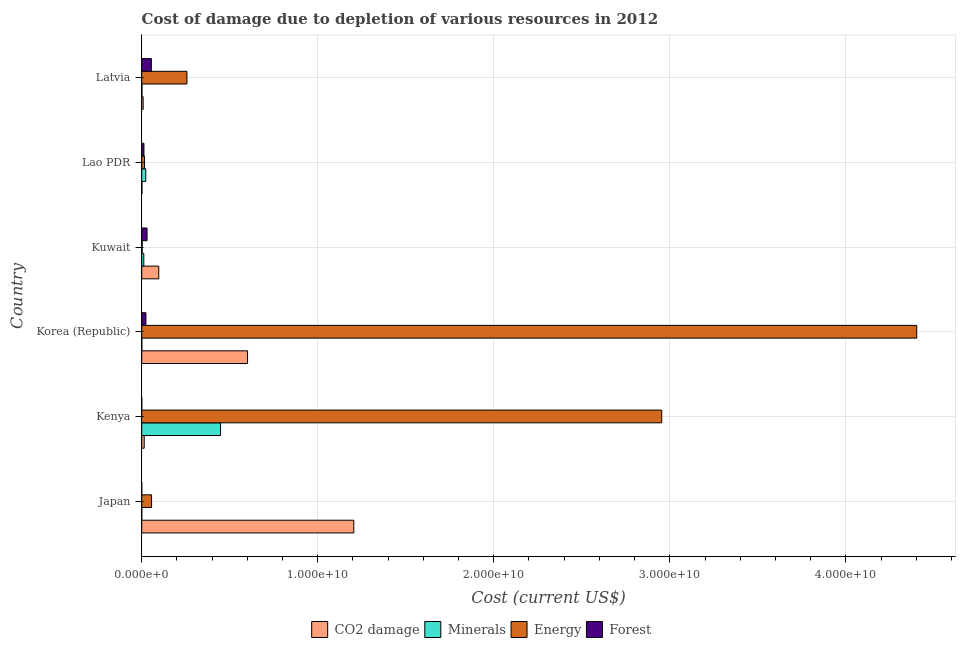How many different coloured bars are there?
Offer a terse response. 4. Are the number of bars per tick equal to the number of legend labels?
Your answer should be very brief. Yes. How many bars are there on the 2nd tick from the top?
Provide a succinct answer. 4. What is the label of the 5th group of bars from the top?
Your answer should be very brief. Kenya. In how many cases, is the number of bars for a given country not equal to the number of legend labels?
Give a very brief answer. 0. What is the cost of damage due to depletion of forests in Latvia?
Give a very brief answer. 5.47e+08. Across all countries, what is the maximum cost of damage due to depletion of coal?
Provide a short and direct response. 1.20e+1. Across all countries, what is the minimum cost of damage due to depletion of coal?
Keep it short and to the point. 1.30e+07. In which country was the cost of damage due to depletion of forests maximum?
Provide a succinct answer. Latvia. In which country was the cost of damage due to depletion of energy minimum?
Provide a short and direct response. Kuwait. What is the total cost of damage due to depletion of energy in the graph?
Offer a terse response. 7.69e+1. What is the difference between the cost of damage due to depletion of minerals in Japan and that in Latvia?
Make the answer very short. -1.47e+07. What is the difference between the cost of damage due to depletion of forests in Korea (Republic) and the cost of damage due to depletion of energy in Lao PDR?
Your response must be concise. 7.86e+07. What is the average cost of damage due to depletion of energy per country?
Give a very brief answer. 1.28e+1. What is the difference between the cost of damage due to depletion of minerals and cost of damage due to depletion of energy in Latvia?
Offer a very short reply. -2.55e+09. What is the ratio of the cost of damage due to depletion of coal in Kenya to that in Latvia?
Your answer should be compact. 1.74. Is the cost of damage due to depletion of forests in Lao PDR less than that in Latvia?
Keep it short and to the point. Yes. Is the difference between the cost of damage due to depletion of coal in Japan and Korea (Republic) greater than the difference between the cost of damage due to depletion of energy in Japan and Korea (Republic)?
Make the answer very short. Yes. What is the difference between the highest and the second highest cost of damage due to depletion of energy?
Give a very brief answer. 1.45e+1. What is the difference between the highest and the lowest cost of damage due to depletion of energy?
Your answer should be very brief. 4.40e+1. Is it the case that in every country, the sum of the cost of damage due to depletion of minerals and cost of damage due to depletion of coal is greater than the sum of cost of damage due to depletion of energy and cost of damage due to depletion of forests?
Your answer should be compact. No. What does the 1st bar from the top in Kuwait represents?
Ensure brevity in your answer.  Forest. What does the 3rd bar from the bottom in Korea (Republic) represents?
Make the answer very short. Energy. Is it the case that in every country, the sum of the cost of damage due to depletion of coal and cost of damage due to depletion of minerals is greater than the cost of damage due to depletion of energy?
Keep it short and to the point. No. Are all the bars in the graph horizontal?
Provide a succinct answer. Yes. How many countries are there in the graph?
Offer a very short reply. 6. What is the difference between two consecutive major ticks on the X-axis?
Provide a short and direct response. 1.00e+1. Does the graph contain grids?
Your answer should be compact. Yes. How many legend labels are there?
Your answer should be very brief. 4. What is the title of the graph?
Offer a terse response. Cost of damage due to depletion of various resources in 2012 . Does "Source data assessment" appear as one of the legend labels in the graph?
Offer a very short reply. No. What is the label or title of the X-axis?
Keep it short and to the point. Cost (current US$). What is the Cost (current US$) in CO2 damage in Japan?
Offer a terse response. 1.20e+1. What is the Cost (current US$) in Minerals in Japan?
Keep it short and to the point. 3.50e+05. What is the Cost (current US$) of Energy in Japan?
Provide a short and direct response. 5.60e+08. What is the Cost (current US$) in Forest in Japan?
Offer a terse response. 2.02e+05. What is the Cost (current US$) in CO2 damage in Kenya?
Your response must be concise. 1.41e+08. What is the Cost (current US$) of Minerals in Kenya?
Ensure brevity in your answer.  4.48e+09. What is the Cost (current US$) of Energy in Kenya?
Keep it short and to the point. 2.95e+1. What is the Cost (current US$) in Forest in Kenya?
Your answer should be very brief. 1.33e+06. What is the Cost (current US$) in CO2 damage in Korea (Republic)?
Make the answer very short. 6.01e+09. What is the Cost (current US$) of Minerals in Korea (Republic)?
Make the answer very short. 8.17e+06. What is the Cost (current US$) in Energy in Korea (Republic)?
Your answer should be compact. 4.40e+1. What is the Cost (current US$) of Forest in Korea (Republic)?
Your answer should be compact. 2.37e+08. What is the Cost (current US$) in CO2 damage in Kuwait?
Keep it short and to the point. 9.68e+08. What is the Cost (current US$) of Minerals in Kuwait?
Give a very brief answer. 1.19e+08. What is the Cost (current US$) in Energy in Kuwait?
Ensure brevity in your answer.  2.46e+07. What is the Cost (current US$) of Forest in Kuwait?
Ensure brevity in your answer.  3.02e+08. What is the Cost (current US$) of CO2 damage in Lao PDR?
Your response must be concise. 1.30e+07. What is the Cost (current US$) in Minerals in Lao PDR?
Your answer should be very brief. 2.30e+08. What is the Cost (current US$) in Energy in Lao PDR?
Your answer should be very brief. 1.59e+08. What is the Cost (current US$) of Forest in Lao PDR?
Offer a very short reply. 1.27e+08. What is the Cost (current US$) in CO2 damage in Latvia?
Ensure brevity in your answer.  8.15e+07. What is the Cost (current US$) of Minerals in Latvia?
Your response must be concise. 1.51e+07. What is the Cost (current US$) of Energy in Latvia?
Ensure brevity in your answer.  2.57e+09. What is the Cost (current US$) in Forest in Latvia?
Offer a very short reply. 5.47e+08. Across all countries, what is the maximum Cost (current US$) of CO2 damage?
Keep it short and to the point. 1.20e+1. Across all countries, what is the maximum Cost (current US$) of Minerals?
Keep it short and to the point. 4.48e+09. Across all countries, what is the maximum Cost (current US$) in Energy?
Offer a very short reply. 4.40e+1. Across all countries, what is the maximum Cost (current US$) in Forest?
Your answer should be compact. 5.47e+08. Across all countries, what is the minimum Cost (current US$) in CO2 damage?
Your response must be concise. 1.30e+07. Across all countries, what is the minimum Cost (current US$) in Minerals?
Make the answer very short. 3.50e+05. Across all countries, what is the minimum Cost (current US$) of Energy?
Make the answer very short. 2.46e+07. Across all countries, what is the minimum Cost (current US$) of Forest?
Offer a terse response. 2.02e+05. What is the total Cost (current US$) of CO2 damage in the graph?
Provide a succinct answer. 1.93e+1. What is the total Cost (current US$) of Minerals in the graph?
Your answer should be compact. 4.85e+09. What is the total Cost (current US$) in Energy in the graph?
Make the answer very short. 7.69e+1. What is the total Cost (current US$) of Forest in the graph?
Your response must be concise. 1.22e+09. What is the difference between the Cost (current US$) in CO2 damage in Japan and that in Kenya?
Offer a very short reply. 1.19e+1. What is the difference between the Cost (current US$) in Minerals in Japan and that in Kenya?
Give a very brief answer. -4.48e+09. What is the difference between the Cost (current US$) of Energy in Japan and that in Kenya?
Offer a terse response. -2.90e+1. What is the difference between the Cost (current US$) in Forest in Japan and that in Kenya?
Ensure brevity in your answer.  -1.12e+06. What is the difference between the Cost (current US$) of CO2 damage in Japan and that in Korea (Republic)?
Provide a short and direct response. 6.04e+09. What is the difference between the Cost (current US$) of Minerals in Japan and that in Korea (Republic)?
Provide a succinct answer. -7.82e+06. What is the difference between the Cost (current US$) of Energy in Japan and that in Korea (Republic)?
Offer a very short reply. -4.35e+1. What is the difference between the Cost (current US$) in Forest in Japan and that in Korea (Republic)?
Offer a very short reply. -2.37e+08. What is the difference between the Cost (current US$) in CO2 damage in Japan and that in Kuwait?
Your response must be concise. 1.11e+1. What is the difference between the Cost (current US$) in Minerals in Japan and that in Kuwait?
Make the answer very short. -1.19e+08. What is the difference between the Cost (current US$) in Energy in Japan and that in Kuwait?
Provide a succinct answer. 5.35e+08. What is the difference between the Cost (current US$) of Forest in Japan and that in Kuwait?
Offer a terse response. -3.02e+08. What is the difference between the Cost (current US$) in CO2 damage in Japan and that in Lao PDR?
Give a very brief answer. 1.20e+1. What is the difference between the Cost (current US$) of Minerals in Japan and that in Lao PDR?
Keep it short and to the point. -2.30e+08. What is the difference between the Cost (current US$) of Energy in Japan and that in Lao PDR?
Your answer should be compact. 4.01e+08. What is the difference between the Cost (current US$) of Forest in Japan and that in Lao PDR?
Offer a terse response. -1.27e+08. What is the difference between the Cost (current US$) of CO2 damage in Japan and that in Latvia?
Give a very brief answer. 1.20e+1. What is the difference between the Cost (current US$) of Minerals in Japan and that in Latvia?
Your answer should be very brief. -1.47e+07. What is the difference between the Cost (current US$) of Energy in Japan and that in Latvia?
Your answer should be compact. -2.01e+09. What is the difference between the Cost (current US$) of Forest in Japan and that in Latvia?
Offer a terse response. -5.47e+08. What is the difference between the Cost (current US$) in CO2 damage in Kenya and that in Korea (Republic)?
Your answer should be compact. -5.87e+09. What is the difference between the Cost (current US$) in Minerals in Kenya and that in Korea (Republic)?
Provide a succinct answer. 4.47e+09. What is the difference between the Cost (current US$) in Energy in Kenya and that in Korea (Republic)?
Provide a short and direct response. -1.45e+1. What is the difference between the Cost (current US$) in Forest in Kenya and that in Korea (Republic)?
Offer a terse response. -2.36e+08. What is the difference between the Cost (current US$) in CO2 damage in Kenya and that in Kuwait?
Give a very brief answer. -8.26e+08. What is the difference between the Cost (current US$) in Minerals in Kenya and that in Kuwait?
Offer a very short reply. 4.36e+09. What is the difference between the Cost (current US$) in Energy in Kenya and that in Kuwait?
Provide a short and direct response. 2.95e+1. What is the difference between the Cost (current US$) of Forest in Kenya and that in Kuwait?
Provide a succinct answer. -3.01e+08. What is the difference between the Cost (current US$) of CO2 damage in Kenya and that in Lao PDR?
Offer a very short reply. 1.28e+08. What is the difference between the Cost (current US$) in Minerals in Kenya and that in Lao PDR?
Make the answer very short. 4.25e+09. What is the difference between the Cost (current US$) in Energy in Kenya and that in Lao PDR?
Give a very brief answer. 2.94e+1. What is the difference between the Cost (current US$) in Forest in Kenya and that in Lao PDR?
Provide a short and direct response. -1.26e+08. What is the difference between the Cost (current US$) in CO2 damage in Kenya and that in Latvia?
Ensure brevity in your answer.  5.99e+07. What is the difference between the Cost (current US$) in Minerals in Kenya and that in Latvia?
Provide a succinct answer. 4.46e+09. What is the difference between the Cost (current US$) in Energy in Kenya and that in Latvia?
Give a very brief answer. 2.70e+1. What is the difference between the Cost (current US$) of Forest in Kenya and that in Latvia?
Make the answer very short. -5.46e+08. What is the difference between the Cost (current US$) of CO2 damage in Korea (Republic) and that in Kuwait?
Ensure brevity in your answer.  5.04e+09. What is the difference between the Cost (current US$) of Minerals in Korea (Republic) and that in Kuwait?
Ensure brevity in your answer.  -1.11e+08. What is the difference between the Cost (current US$) in Energy in Korea (Republic) and that in Kuwait?
Offer a very short reply. 4.40e+1. What is the difference between the Cost (current US$) in Forest in Korea (Republic) and that in Kuwait?
Ensure brevity in your answer.  -6.49e+07. What is the difference between the Cost (current US$) of CO2 damage in Korea (Republic) and that in Lao PDR?
Your response must be concise. 6.00e+09. What is the difference between the Cost (current US$) of Minerals in Korea (Republic) and that in Lao PDR?
Make the answer very short. -2.22e+08. What is the difference between the Cost (current US$) in Energy in Korea (Republic) and that in Lao PDR?
Your answer should be compact. 4.39e+1. What is the difference between the Cost (current US$) of Forest in Korea (Republic) and that in Lao PDR?
Provide a short and direct response. 1.11e+08. What is the difference between the Cost (current US$) of CO2 damage in Korea (Republic) and that in Latvia?
Ensure brevity in your answer.  5.93e+09. What is the difference between the Cost (current US$) in Minerals in Korea (Republic) and that in Latvia?
Offer a very short reply. -6.92e+06. What is the difference between the Cost (current US$) in Energy in Korea (Republic) and that in Latvia?
Your response must be concise. 4.15e+1. What is the difference between the Cost (current US$) in Forest in Korea (Republic) and that in Latvia?
Ensure brevity in your answer.  -3.10e+08. What is the difference between the Cost (current US$) in CO2 damage in Kuwait and that in Lao PDR?
Your answer should be very brief. 9.55e+08. What is the difference between the Cost (current US$) of Minerals in Kuwait and that in Lao PDR?
Keep it short and to the point. -1.12e+08. What is the difference between the Cost (current US$) of Energy in Kuwait and that in Lao PDR?
Your answer should be compact. -1.34e+08. What is the difference between the Cost (current US$) in Forest in Kuwait and that in Lao PDR?
Ensure brevity in your answer.  1.75e+08. What is the difference between the Cost (current US$) in CO2 damage in Kuwait and that in Latvia?
Keep it short and to the point. 8.86e+08. What is the difference between the Cost (current US$) of Minerals in Kuwait and that in Latvia?
Make the answer very short. 1.04e+08. What is the difference between the Cost (current US$) of Energy in Kuwait and that in Latvia?
Offer a very short reply. -2.54e+09. What is the difference between the Cost (current US$) of Forest in Kuwait and that in Latvia?
Ensure brevity in your answer.  -2.45e+08. What is the difference between the Cost (current US$) of CO2 damage in Lao PDR and that in Latvia?
Provide a short and direct response. -6.86e+07. What is the difference between the Cost (current US$) in Minerals in Lao PDR and that in Latvia?
Offer a very short reply. 2.15e+08. What is the difference between the Cost (current US$) in Energy in Lao PDR and that in Latvia?
Keep it short and to the point. -2.41e+09. What is the difference between the Cost (current US$) of Forest in Lao PDR and that in Latvia?
Keep it short and to the point. -4.20e+08. What is the difference between the Cost (current US$) in CO2 damage in Japan and the Cost (current US$) in Minerals in Kenya?
Ensure brevity in your answer.  7.57e+09. What is the difference between the Cost (current US$) in CO2 damage in Japan and the Cost (current US$) in Energy in Kenya?
Make the answer very short. -1.75e+1. What is the difference between the Cost (current US$) of CO2 damage in Japan and the Cost (current US$) of Forest in Kenya?
Keep it short and to the point. 1.20e+1. What is the difference between the Cost (current US$) in Minerals in Japan and the Cost (current US$) in Energy in Kenya?
Your response must be concise. -2.95e+1. What is the difference between the Cost (current US$) in Minerals in Japan and the Cost (current US$) in Forest in Kenya?
Your answer should be compact. -9.76e+05. What is the difference between the Cost (current US$) of Energy in Japan and the Cost (current US$) of Forest in Kenya?
Give a very brief answer. 5.58e+08. What is the difference between the Cost (current US$) of CO2 damage in Japan and the Cost (current US$) of Minerals in Korea (Republic)?
Offer a terse response. 1.20e+1. What is the difference between the Cost (current US$) in CO2 damage in Japan and the Cost (current US$) in Energy in Korea (Republic)?
Ensure brevity in your answer.  -3.20e+1. What is the difference between the Cost (current US$) in CO2 damage in Japan and the Cost (current US$) in Forest in Korea (Republic)?
Give a very brief answer. 1.18e+1. What is the difference between the Cost (current US$) in Minerals in Japan and the Cost (current US$) in Energy in Korea (Republic)?
Offer a very short reply. -4.40e+1. What is the difference between the Cost (current US$) of Minerals in Japan and the Cost (current US$) of Forest in Korea (Republic)?
Give a very brief answer. -2.37e+08. What is the difference between the Cost (current US$) in Energy in Japan and the Cost (current US$) in Forest in Korea (Republic)?
Make the answer very short. 3.22e+08. What is the difference between the Cost (current US$) of CO2 damage in Japan and the Cost (current US$) of Minerals in Kuwait?
Your answer should be compact. 1.19e+1. What is the difference between the Cost (current US$) of CO2 damage in Japan and the Cost (current US$) of Energy in Kuwait?
Offer a terse response. 1.20e+1. What is the difference between the Cost (current US$) in CO2 damage in Japan and the Cost (current US$) in Forest in Kuwait?
Keep it short and to the point. 1.17e+1. What is the difference between the Cost (current US$) of Minerals in Japan and the Cost (current US$) of Energy in Kuwait?
Your response must be concise. -2.43e+07. What is the difference between the Cost (current US$) of Minerals in Japan and the Cost (current US$) of Forest in Kuwait?
Ensure brevity in your answer.  -3.02e+08. What is the difference between the Cost (current US$) in Energy in Japan and the Cost (current US$) in Forest in Kuwait?
Give a very brief answer. 2.57e+08. What is the difference between the Cost (current US$) of CO2 damage in Japan and the Cost (current US$) of Minerals in Lao PDR?
Provide a succinct answer. 1.18e+1. What is the difference between the Cost (current US$) in CO2 damage in Japan and the Cost (current US$) in Energy in Lao PDR?
Give a very brief answer. 1.19e+1. What is the difference between the Cost (current US$) in CO2 damage in Japan and the Cost (current US$) in Forest in Lao PDR?
Provide a succinct answer. 1.19e+1. What is the difference between the Cost (current US$) in Minerals in Japan and the Cost (current US$) in Energy in Lao PDR?
Offer a terse response. -1.59e+08. What is the difference between the Cost (current US$) of Minerals in Japan and the Cost (current US$) of Forest in Lao PDR?
Ensure brevity in your answer.  -1.27e+08. What is the difference between the Cost (current US$) in Energy in Japan and the Cost (current US$) in Forest in Lao PDR?
Offer a very short reply. 4.33e+08. What is the difference between the Cost (current US$) in CO2 damage in Japan and the Cost (current US$) in Minerals in Latvia?
Offer a terse response. 1.20e+1. What is the difference between the Cost (current US$) in CO2 damage in Japan and the Cost (current US$) in Energy in Latvia?
Give a very brief answer. 9.48e+09. What is the difference between the Cost (current US$) in CO2 damage in Japan and the Cost (current US$) in Forest in Latvia?
Offer a very short reply. 1.15e+1. What is the difference between the Cost (current US$) of Minerals in Japan and the Cost (current US$) of Energy in Latvia?
Offer a terse response. -2.57e+09. What is the difference between the Cost (current US$) in Minerals in Japan and the Cost (current US$) in Forest in Latvia?
Your answer should be compact. -5.47e+08. What is the difference between the Cost (current US$) of Energy in Japan and the Cost (current US$) of Forest in Latvia?
Your answer should be very brief. 1.25e+07. What is the difference between the Cost (current US$) of CO2 damage in Kenya and the Cost (current US$) of Minerals in Korea (Republic)?
Your answer should be compact. 1.33e+08. What is the difference between the Cost (current US$) in CO2 damage in Kenya and the Cost (current US$) in Energy in Korea (Republic)?
Ensure brevity in your answer.  -4.39e+1. What is the difference between the Cost (current US$) of CO2 damage in Kenya and the Cost (current US$) of Forest in Korea (Republic)?
Your answer should be very brief. -9.61e+07. What is the difference between the Cost (current US$) in Minerals in Kenya and the Cost (current US$) in Energy in Korea (Republic)?
Your response must be concise. -3.96e+1. What is the difference between the Cost (current US$) in Minerals in Kenya and the Cost (current US$) in Forest in Korea (Republic)?
Keep it short and to the point. 4.24e+09. What is the difference between the Cost (current US$) in Energy in Kenya and the Cost (current US$) in Forest in Korea (Republic)?
Provide a short and direct response. 2.93e+1. What is the difference between the Cost (current US$) in CO2 damage in Kenya and the Cost (current US$) in Minerals in Kuwait?
Offer a very short reply. 2.25e+07. What is the difference between the Cost (current US$) in CO2 damage in Kenya and the Cost (current US$) in Energy in Kuwait?
Your answer should be compact. 1.17e+08. What is the difference between the Cost (current US$) of CO2 damage in Kenya and the Cost (current US$) of Forest in Kuwait?
Give a very brief answer. -1.61e+08. What is the difference between the Cost (current US$) of Minerals in Kenya and the Cost (current US$) of Energy in Kuwait?
Your answer should be very brief. 4.45e+09. What is the difference between the Cost (current US$) in Minerals in Kenya and the Cost (current US$) in Forest in Kuwait?
Offer a very short reply. 4.18e+09. What is the difference between the Cost (current US$) in Energy in Kenya and the Cost (current US$) in Forest in Kuwait?
Your response must be concise. 2.92e+1. What is the difference between the Cost (current US$) of CO2 damage in Kenya and the Cost (current US$) of Minerals in Lao PDR?
Offer a terse response. -8.90e+07. What is the difference between the Cost (current US$) of CO2 damage in Kenya and the Cost (current US$) of Energy in Lao PDR?
Give a very brief answer. -1.75e+07. What is the difference between the Cost (current US$) in CO2 damage in Kenya and the Cost (current US$) in Forest in Lao PDR?
Your answer should be very brief. 1.45e+07. What is the difference between the Cost (current US$) of Minerals in Kenya and the Cost (current US$) of Energy in Lao PDR?
Keep it short and to the point. 4.32e+09. What is the difference between the Cost (current US$) in Minerals in Kenya and the Cost (current US$) in Forest in Lao PDR?
Give a very brief answer. 4.35e+09. What is the difference between the Cost (current US$) of Energy in Kenya and the Cost (current US$) of Forest in Lao PDR?
Offer a very short reply. 2.94e+1. What is the difference between the Cost (current US$) in CO2 damage in Kenya and the Cost (current US$) in Minerals in Latvia?
Provide a succinct answer. 1.26e+08. What is the difference between the Cost (current US$) of CO2 damage in Kenya and the Cost (current US$) of Energy in Latvia?
Make the answer very short. -2.43e+09. What is the difference between the Cost (current US$) of CO2 damage in Kenya and the Cost (current US$) of Forest in Latvia?
Give a very brief answer. -4.06e+08. What is the difference between the Cost (current US$) of Minerals in Kenya and the Cost (current US$) of Energy in Latvia?
Your answer should be compact. 1.91e+09. What is the difference between the Cost (current US$) of Minerals in Kenya and the Cost (current US$) of Forest in Latvia?
Make the answer very short. 3.93e+09. What is the difference between the Cost (current US$) of Energy in Kenya and the Cost (current US$) of Forest in Latvia?
Your answer should be very brief. 2.90e+1. What is the difference between the Cost (current US$) of CO2 damage in Korea (Republic) and the Cost (current US$) of Minerals in Kuwait?
Your answer should be very brief. 5.89e+09. What is the difference between the Cost (current US$) of CO2 damage in Korea (Republic) and the Cost (current US$) of Energy in Kuwait?
Keep it short and to the point. 5.99e+09. What is the difference between the Cost (current US$) in CO2 damage in Korea (Republic) and the Cost (current US$) in Forest in Kuwait?
Give a very brief answer. 5.71e+09. What is the difference between the Cost (current US$) in Minerals in Korea (Republic) and the Cost (current US$) in Energy in Kuwait?
Your response must be concise. -1.65e+07. What is the difference between the Cost (current US$) in Minerals in Korea (Republic) and the Cost (current US$) in Forest in Kuwait?
Provide a short and direct response. -2.94e+08. What is the difference between the Cost (current US$) of Energy in Korea (Republic) and the Cost (current US$) of Forest in Kuwait?
Make the answer very short. 4.37e+1. What is the difference between the Cost (current US$) of CO2 damage in Korea (Republic) and the Cost (current US$) of Minerals in Lao PDR?
Provide a short and direct response. 5.78e+09. What is the difference between the Cost (current US$) in CO2 damage in Korea (Republic) and the Cost (current US$) in Energy in Lao PDR?
Your answer should be compact. 5.85e+09. What is the difference between the Cost (current US$) in CO2 damage in Korea (Republic) and the Cost (current US$) in Forest in Lao PDR?
Your response must be concise. 5.88e+09. What is the difference between the Cost (current US$) of Minerals in Korea (Republic) and the Cost (current US$) of Energy in Lao PDR?
Provide a succinct answer. -1.51e+08. What is the difference between the Cost (current US$) in Minerals in Korea (Republic) and the Cost (current US$) in Forest in Lao PDR?
Keep it short and to the point. -1.19e+08. What is the difference between the Cost (current US$) in Energy in Korea (Republic) and the Cost (current US$) in Forest in Lao PDR?
Your response must be concise. 4.39e+1. What is the difference between the Cost (current US$) of CO2 damage in Korea (Republic) and the Cost (current US$) of Minerals in Latvia?
Keep it short and to the point. 6.00e+09. What is the difference between the Cost (current US$) of CO2 damage in Korea (Republic) and the Cost (current US$) of Energy in Latvia?
Keep it short and to the point. 3.44e+09. What is the difference between the Cost (current US$) in CO2 damage in Korea (Republic) and the Cost (current US$) in Forest in Latvia?
Offer a terse response. 5.46e+09. What is the difference between the Cost (current US$) of Minerals in Korea (Republic) and the Cost (current US$) of Energy in Latvia?
Provide a succinct answer. -2.56e+09. What is the difference between the Cost (current US$) in Minerals in Korea (Republic) and the Cost (current US$) in Forest in Latvia?
Provide a short and direct response. -5.39e+08. What is the difference between the Cost (current US$) in Energy in Korea (Republic) and the Cost (current US$) in Forest in Latvia?
Give a very brief answer. 4.35e+1. What is the difference between the Cost (current US$) of CO2 damage in Kuwait and the Cost (current US$) of Minerals in Lao PDR?
Ensure brevity in your answer.  7.37e+08. What is the difference between the Cost (current US$) of CO2 damage in Kuwait and the Cost (current US$) of Energy in Lao PDR?
Your answer should be very brief. 8.09e+08. What is the difference between the Cost (current US$) of CO2 damage in Kuwait and the Cost (current US$) of Forest in Lao PDR?
Keep it short and to the point. 8.41e+08. What is the difference between the Cost (current US$) in Minerals in Kuwait and the Cost (current US$) in Energy in Lao PDR?
Give a very brief answer. -4.00e+07. What is the difference between the Cost (current US$) in Minerals in Kuwait and the Cost (current US$) in Forest in Lao PDR?
Provide a short and direct response. -8.04e+06. What is the difference between the Cost (current US$) of Energy in Kuwait and the Cost (current US$) of Forest in Lao PDR?
Provide a succinct answer. -1.02e+08. What is the difference between the Cost (current US$) in CO2 damage in Kuwait and the Cost (current US$) in Minerals in Latvia?
Provide a succinct answer. 9.53e+08. What is the difference between the Cost (current US$) in CO2 damage in Kuwait and the Cost (current US$) in Energy in Latvia?
Ensure brevity in your answer.  -1.60e+09. What is the difference between the Cost (current US$) in CO2 damage in Kuwait and the Cost (current US$) in Forest in Latvia?
Offer a very short reply. 4.21e+08. What is the difference between the Cost (current US$) of Minerals in Kuwait and the Cost (current US$) of Energy in Latvia?
Give a very brief answer. -2.45e+09. What is the difference between the Cost (current US$) of Minerals in Kuwait and the Cost (current US$) of Forest in Latvia?
Ensure brevity in your answer.  -4.28e+08. What is the difference between the Cost (current US$) of Energy in Kuwait and the Cost (current US$) of Forest in Latvia?
Make the answer very short. -5.22e+08. What is the difference between the Cost (current US$) in CO2 damage in Lao PDR and the Cost (current US$) in Minerals in Latvia?
Your answer should be compact. -2.13e+06. What is the difference between the Cost (current US$) of CO2 damage in Lao PDR and the Cost (current US$) of Energy in Latvia?
Ensure brevity in your answer.  -2.56e+09. What is the difference between the Cost (current US$) of CO2 damage in Lao PDR and the Cost (current US$) of Forest in Latvia?
Give a very brief answer. -5.34e+08. What is the difference between the Cost (current US$) in Minerals in Lao PDR and the Cost (current US$) in Energy in Latvia?
Offer a very short reply. -2.34e+09. What is the difference between the Cost (current US$) in Minerals in Lao PDR and the Cost (current US$) in Forest in Latvia?
Offer a terse response. -3.17e+08. What is the difference between the Cost (current US$) in Energy in Lao PDR and the Cost (current US$) in Forest in Latvia?
Offer a very short reply. -3.88e+08. What is the average Cost (current US$) of CO2 damage per country?
Offer a very short reply. 3.21e+09. What is the average Cost (current US$) in Minerals per country?
Provide a short and direct response. 8.08e+08. What is the average Cost (current US$) in Energy per country?
Offer a terse response. 1.28e+1. What is the average Cost (current US$) of Forest per country?
Keep it short and to the point. 2.03e+08. What is the difference between the Cost (current US$) of CO2 damage and Cost (current US$) of Minerals in Japan?
Provide a short and direct response. 1.20e+1. What is the difference between the Cost (current US$) in CO2 damage and Cost (current US$) in Energy in Japan?
Keep it short and to the point. 1.15e+1. What is the difference between the Cost (current US$) of CO2 damage and Cost (current US$) of Forest in Japan?
Your response must be concise. 1.20e+1. What is the difference between the Cost (current US$) in Minerals and Cost (current US$) in Energy in Japan?
Your answer should be very brief. -5.59e+08. What is the difference between the Cost (current US$) in Minerals and Cost (current US$) in Forest in Japan?
Your response must be concise. 1.48e+05. What is the difference between the Cost (current US$) in Energy and Cost (current US$) in Forest in Japan?
Keep it short and to the point. 5.59e+08. What is the difference between the Cost (current US$) in CO2 damage and Cost (current US$) in Minerals in Kenya?
Your answer should be very brief. -4.34e+09. What is the difference between the Cost (current US$) of CO2 damage and Cost (current US$) of Energy in Kenya?
Ensure brevity in your answer.  -2.94e+1. What is the difference between the Cost (current US$) in CO2 damage and Cost (current US$) in Forest in Kenya?
Offer a terse response. 1.40e+08. What is the difference between the Cost (current US$) in Minerals and Cost (current US$) in Energy in Kenya?
Your answer should be compact. -2.51e+1. What is the difference between the Cost (current US$) in Minerals and Cost (current US$) in Forest in Kenya?
Provide a short and direct response. 4.48e+09. What is the difference between the Cost (current US$) in Energy and Cost (current US$) in Forest in Kenya?
Keep it short and to the point. 2.95e+1. What is the difference between the Cost (current US$) in CO2 damage and Cost (current US$) in Minerals in Korea (Republic)?
Ensure brevity in your answer.  6.00e+09. What is the difference between the Cost (current US$) of CO2 damage and Cost (current US$) of Energy in Korea (Republic)?
Ensure brevity in your answer.  -3.80e+1. What is the difference between the Cost (current US$) in CO2 damage and Cost (current US$) in Forest in Korea (Republic)?
Offer a very short reply. 5.77e+09. What is the difference between the Cost (current US$) of Minerals and Cost (current US$) of Energy in Korea (Republic)?
Give a very brief answer. -4.40e+1. What is the difference between the Cost (current US$) of Minerals and Cost (current US$) of Forest in Korea (Republic)?
Your answer should be very brief. -2.29e+08. What is the difference between the Cost (current US$) in Energy and Cost (current US$) in Forest in Korea (Republic)?
Keep it short and to the point. 4.38e+1. What is the difference between the Cost (current US$) in CO2 damage and Cost (current US$) in Minerals in Kuwait?
Ensure brevity in your answer.  8.49e+08. What is the difference between the Cost (current US$) in CO2 damage and Cost (current US$) in Energy in Kuwait?
Give a very brief answer. 9.43e+08. What is the difference between the Cost (current US$) in CO2 damage and Cost (current US$) in Forest in Kuwait?
Your answer should be very brief. 6.65e+08. What is the difference between the Cost (current US$) in Minerals and Cost (current US$) in Energy in Kuwait?
Provide a succinct answer. 9.43e+07. What is the difference between the Cost (current US$) in Minerals and Cost (current US$) in Forest in Kuwait?
Your answer should be very brief. -1.84e+08. What is the difference between the Cost (current US$) of Energy and Cost (current US$) of Forest in Kuwait?
Ensure brevity in your answer.  -2.78e+08. What is the difference between the Cost (current US$) of CO2 damage and Cost (current US$) of Minerals in Lao PDR?
Give a very brief answer. -2.18e+08. What is the difference between the Cost (current US$) in CO2 damage and Cost (current US$) in Energy in Lao PDR?
Give a very brief answer. -1.46e+08. What is the difference between the Cost (current US$) of CO2 damage and Cost (current US$) of Forest in Lao PDR?
Make the answer very short. -1.14e+08. What is the difference between the Cost (current US$) in Minerals and Cost (current US$) in Energy in Lao PDR?
Your answer should be very brief. 7.16e+07. What is the difference between the Cost (current US$) in Minerals and Cost (current US$) in Forest in Lao PDR?
Give a very brief answer. 1.03e+08. What is the difference between the Cost (current US$) of Energy and Cost (current US$) of Forest in Lao PDR?
Your answer should be very brief. 3.19e+07. What is the difference between the Cost (current US$) in CO2 damage and Cost (current US$) in Minerals in Latvia?
Your answer should be very brief. 6.64e+07. What is the difference between the Cost (current US$) in CO2 damage and Cost (current US$) in Energy in Latvia?
Provide a short and direct response. -2.49e+09. What is the difference between the Cost (current US$) in CO2 damage and Cost (current US$) in Forest in Latvia?
Make the answer very short. -4.66e+08. What is the difference between the Cost (current US$) in Minerals and Cost (current US$) in Energy in Latvia?
Your answer should be very brief. -2.55e+09. What is the difference between the Cost (current US$) of Minerals and Cost (current US$) of Forest in Latvia?
Ensure brevity in your answer.  -5.32e+08. What is the difference between the Cost (current US$) of Energy and Cost (current US$) of Forest in Latvia?
Provide a succinct answer. 2.02e+09. What is the ratio of the Cost (current US$) in CO2 damage in Japan to that in Kenya?
Offer a terse response. 85.19. What is the ratio of the Cost (current US$) of Energy in Japan to that in Kenya?
Your answer should be very brief. 0.02. What is the ratio of the Cost (current US$) in Forest in Japan to that in Kenya?
Give a very brief answer. 0.15. What is the ratio of the Cost (current US$) in CO2 damage in Japan to that in Korea (Republic)?
Your response must be concise. 2. What is the ratio of the Cost (current US$) in Minerals in Japan to that in Korea (Republic)?
Keep it short and to the point. 0.04. What is the ratio of the Cost (current US$) in Energy in Japan to that in Korea (Republic)?
Your answer should be very brief. 0.01. What is the ratio of the Cost (current US$) in Forest in Japan to that in Korea (Republic)?
Offer a terse response. 0. What is the ratio of the Cost (current US$) of CO2 damage in Japan to that in Kuwait?
Make the answer very short. 12.45. What is the ratio of the Cost (current US$) in Minerals in Japan to that in Kuwait?
Offer a very short reply. 0. What is the ratio of the Cost (current US$) in Energy in Japan to that in Kuwait?
Keep it short and to the point. 22.71. What is the ratio of the Cost (current US$) in Forest in Japan to that in Kuwait?
Give a very brief answer. 0. What is the ratio of the Cost (current US$) of CO2 damage in Japan to that in Lao PDR?
Offer a terse response. 930.11. What is the ratio of the Cost (current US$) of Minerals in Japan to that in Lao PDR?
Your response must be concise. 0. What is the ratio of the Cost (current US$) of Energy in Japan to that in Lao PDR?
Your answer should be compact. 3.52. What is the ratio of the Cost (current US$) of Forest in Japan to that in Lao PDR?
Your response must be concise. 0. What is the ratio of the Cost (current US$) of CO2 damage in Japan to that in Latvia?
Provide a short and direct response. 147.8. What is the ratio of the Cost (current US$) of Minerals in Japan to that in Latvia?
Make the answer very short. 0.02. What is the ratio of the Cost (current US$) of Energy in Japan to that in Latvia?
Provide a short and direct response. 0.22. What is the ratio of the Cost (current US$) of CO2 damage in Kenya to that in Korea (Republic)?
Keep it short and to the point. 0.02. What is the ratio of the Cost (current US$) of Minerals in Kenya to that in Korea (Republic)?
Your answer should be compact. 548.05. What is the ratio of the Cost (current US$) of Energy in Kenya to that in Korea (Republic)?
Your response must be concise. 0.67. What is the ratio of the Cost (current US$) of Forest in Kenya to that in Korea (Republic)?
Ensure brevity in your answer.  0.01. What is the ratio of the Cost (current US$) of CO2 damage in Kenya to that in Kuwait?
Ensure brevity in your answer.  0.15. What is the ratio of the Cost (current US$) of Minerals in Kenya to that in Kuwait?
Provide a succinct answer. 37.65. What is the ratio of the Cost (current US$) of Energy in Kenya to that in Kuwait?
Offer a terse response. 1199.3. What is the ratio of the Cost (current US$) in Forest in Kenya to that in Kuwait?
Your answer should be very brief. 0. What is the ratio of the Cost (current US$) in CO2 damage in Kenya to that in Lao PDR?
Your answer should be very brief. 10.92. What is the ratio of the Cost (current US$) in Minerals in Kenya to that in Lao PDR?
Your response must be concise. 19.43. What is the ratio of the Cost (current US$) in Energy in Kenya to that in Lao PDR?
Your response must be concise. 185.92. What is the ratio of the Cost (current US$) in Forest in Kenya to that in Lao PDR?
Offer a very short reply. 0.01. What is the ratio of the Cost (current US$) in CO2 damage in Kenya to that in Latvia?
Your answer should be compact. 1.73. What is the ratio of the Cost (current US$) of Minerals in Kenya to that in Latvia?
Give a very brief answer. 296.76. What is the ratio of the Cost (current US$) of Energy in Kenya to that in Latvia?
Offer a very short reply. 11.5. What is the ratio of the Cost (current US$) in Forest in Kenya to that in Latvia?
Make the answer very short. 0. What is the ratio of the Cost (current US$) in CO2 damage in Korea (Republic) to that in Kuwait?
Offer a terse response. 6.21. What is the ratio of the Cost (current US$) in Minerals in Korea (Republic) to that in Kuwait?
Your response must be concise. 0.07. What is the ratio of the Cost (current US$) of Energy in Korea (Republic) to that in Kuwait?
Offer a very short reply. 1787.41. What is the ratio of the Cost (current US$) of Forest in Korea (Republic) to that in Kuwait?
Offer a terse response. 0.79. What is the ratio of the Cost (current US$) of CO2 damage in Korea (Republic) to that in Lao PDR?
Your answer should be very brief. 464.05. What is the ratio of the Cost (current US$) of Minerals in Korea (Republic) to that in Lao PDR?
Your answer should be compact. 0.04. What is the ratio of the Cost (current US$) of Energy in Korea (Republic) to that in Lao PDR?
Your answer should be very brief. 277.09. What is the ratio of the Cost (current US$) of Forest in Korea (Republic) to that in Lao PDR?
Make the answer very short. 1.87. What is the ratio of the Cost (current US$) of CO2 damage in Korea (Republic) to that in Latvia?
Provide a short and direct response. 73.74. What is the ratio of the Cost (current US$) in Minerals in Korea (Republic) to that in Latvia?
Offer a very short reply. 0.54. What is the ratio of the Cost (current US$) in Energy in Korea (Republic) to that in Latvia?
Ensure brevity in your answer.  17.14. What is the ratio of the Cost (current US$) of Forest in Korea (Republic) to that in Latvia?
Keep it short and to the point. 0.43. What is the ratio of the Cost (current US$) of CO2 damage in Kuwait to that in Lao PDR?
Keep it short and to the point. 74.7. What is the ratio of the Cost (current US$) in Minerals in Kuwait to that in Lao PDR?
Make the answer very short. 0.52. What is the ratio of the Cost (current US$) of Energy in Kuwait to that in Lao PDR?
Your answer should be compact. 0.15. What is the ratio of the Cost (current US$) in Forest in Kuwait to that in Lao PDR?
Ensure brevity in your answer.  2.38. What is the ratio of the Cost (current US$) of CO2 damage in Kuwait to that in Latvia?
Give a very brief answer. 11.87. What is the ratio of the Cost (current US$) in Minerals in Kuwait to that in Latvia?
Give a very brief answer. 7.88. What is the ratio of the Cost (current US$) in Energy in Kuwait to that in Latvia?
Your response must be concise. 0.01. What is the ratio of the Cost (current US$) in Forest in Kuwait to that in Latvia?
Provide a short and direct response. 0.55. What is the ratio of the Cost (current US$) in CO2 damage in Lao PDR to that in Latvia?
Your answer should be compact. 0.16. What is the ratio of the Cost (current US$) in Minerals in Lao PDR to that in Latvia?
Your answer should be compact. 15.27. What is the ratio of the Cost (current US$) in Energy in Lao PDR to that in Latvia?
Keep it short and to the point. 0.06. What is the ratio of the Cost (current US$) of Forest in Lao PDR to that in Latvia?
Keep it short and to the point. 0.23. What is the difference between the highest and the second highest Cost (current US$) of CO2 damage?
Keep it short and to the point. 6.04e+09. What is the difference between the highest and the second highest Cost (current US$) in Minerals?
Make the answer very short. 4.25e+09. What is the difference between the highest and the second highest Cost (current US$) of Energy?
Offer a very short reply. 1.45e+1. What is the difference between the highest and the second highest Cost (current US$) of Forest?
Offer a very short reply. 2.45e+08. What is the difference between the highest and the lowest Cost (current US$) in CO2 damage?
Ensure brevity in your answer.  1.20e+1. What is the difference between the highest and the lowest Cost (current US$) in Minerals?
Keep it short and to the point. 4.48e+09. What is the difference between the highest and the lowest Cost (current US$) in Energy?
Offer a terse response. 4.40e+1. What is the difference between the highest and the lowest Cost (current US$) in Forest?
Offer a very short reply. 5.47e+08. 